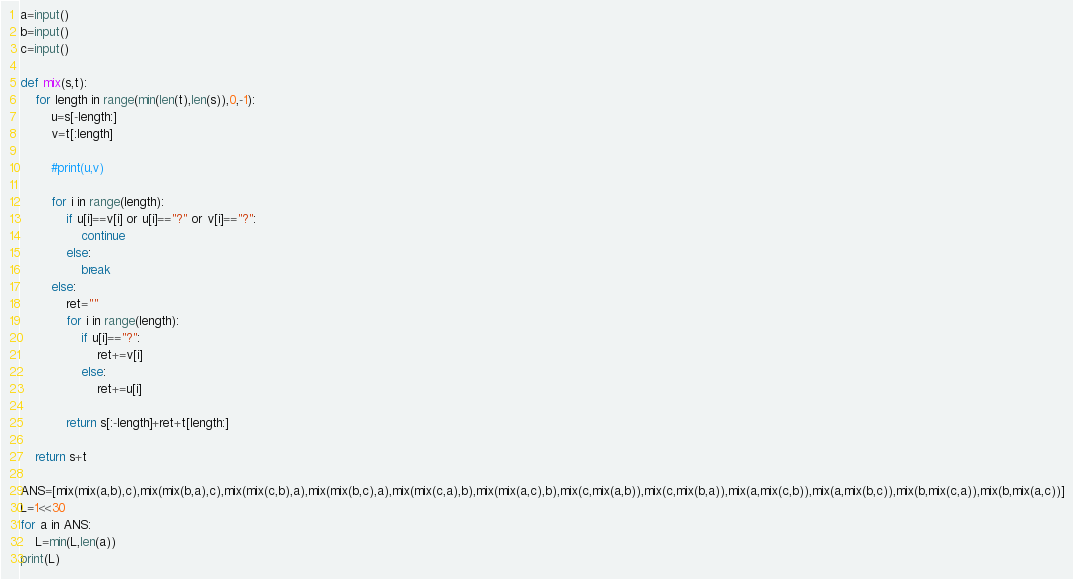<code> <loc_0><loc_0><loc_500><loc_500><_Python_>a=input()
b=input()
c=input()

def mix(s,t):
    for length in range(min(len(t),len(s)),0,-1):
        u=s[-length:]
        v=t[:length]

        #print(u,v)

        for i in range(length):
            if u[i]==v[i] or u[i]=="?" or v[i]=="?":
                continue
            else:
                break
        else:
            ret=""
            for i in range(length):
                if u[i]=="?":
                    ret+=v[i]
                else:
                    ret+=u[i]
                
            return s[:-length]+ret+t[length:]

    return s+t

ANS=[mix(mix(a,b),c),mix(mix(b,a),c),mix(mix(c,b),a),mix(mix(b,c),a),mix(mix(c,a),b),mix(mix(a,c),b),mix(c,mix(a,b)),mix(c,mix(b,a)),mix(a,mix(c,b)),mix(a,mix(b,c)),mix(b,mix(c,a)),mix(b,mix(a,c))]
L=1<<30
for a in ANS:
    L=min(L,len(a))
print(L)</code> 